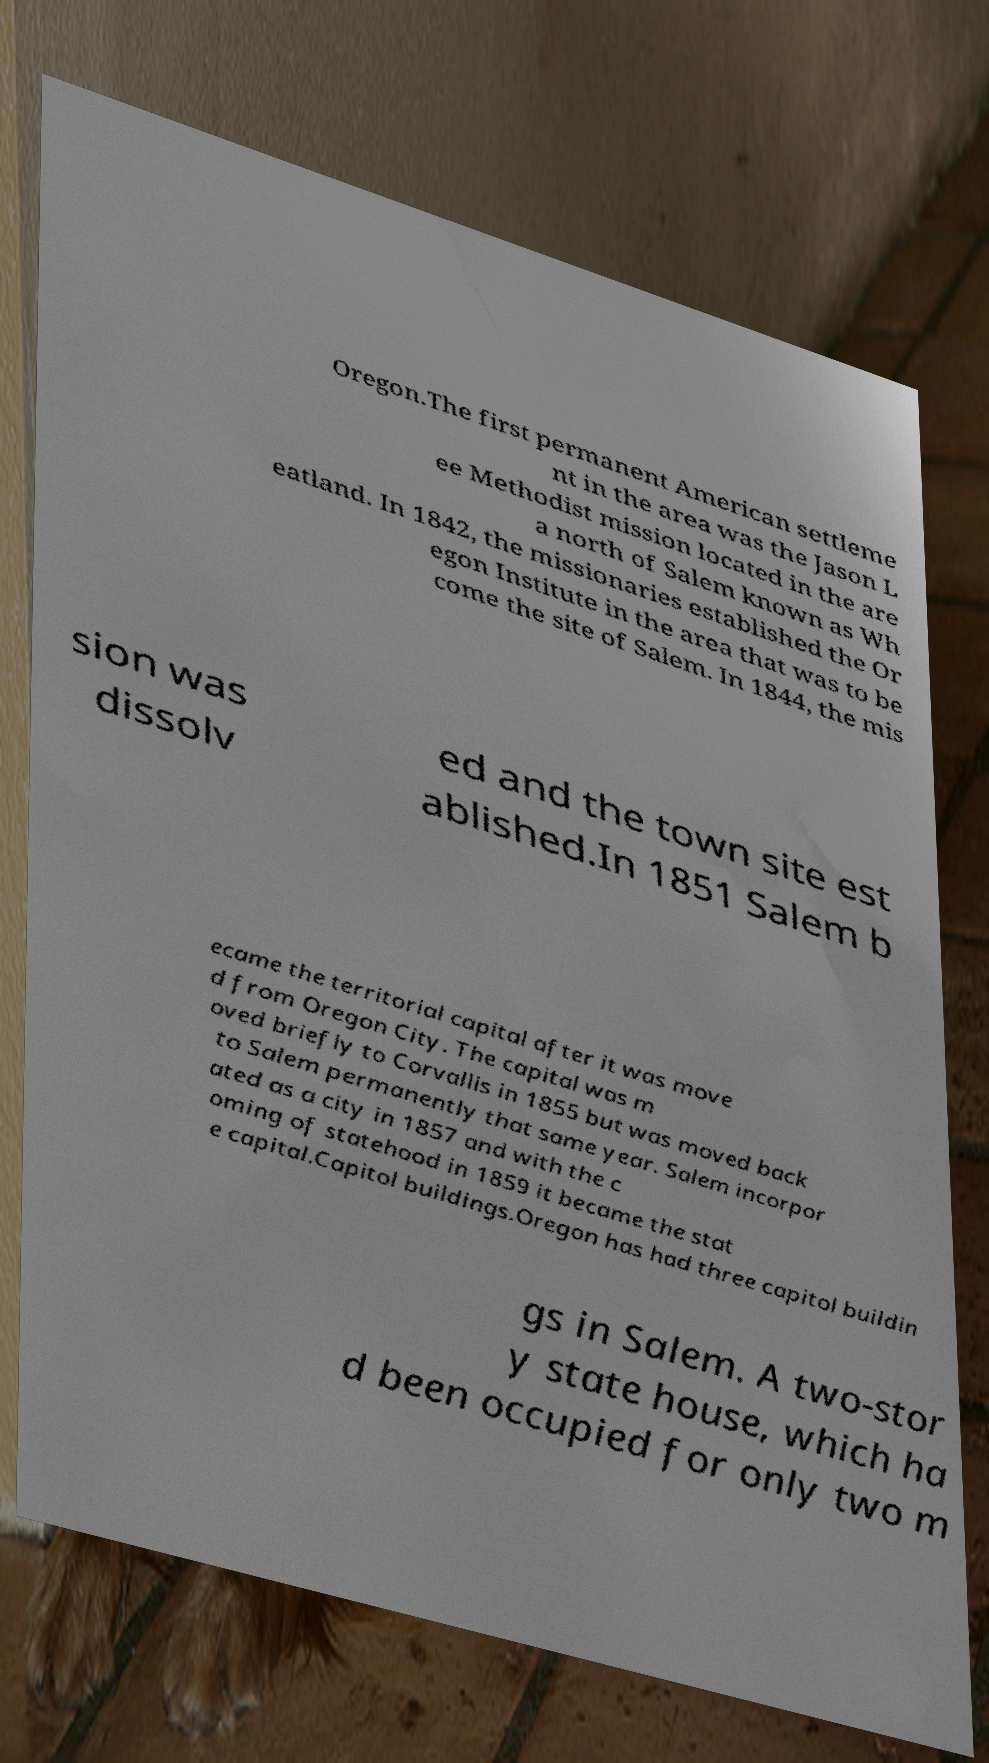Could you assist in decoding the text presented in this image and type it out clearly? Oregon.The first permanent American settleme nt in the area was the Jason L ee Methodist mission located in the are a north of Salem known as Wh eatland. In 1842, the missionaries established the Or egon Institute in the area that was to be come the site of Salem. In 1844, the mis sion was dissolv ed and the town site est ablished.In 1851 Salem b ecame the territorial capital after it was move d from Oregon City. The capital was m oved briefly to Corvallis in 1855 but was moved back to Salem permanently that same year. Salem incorpor ated as a city in 1857 and with the c oming of statehood in 1859 it became the stat e capital.Capitol buildings.Oregon has had three capitol buildin gs in Salem. A two-stor y state house, which ha d been occupied for only two m 